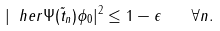<formula> <loc_0><loc_0><loc_500><loc_500>| \ h e r { \Psi ( \tilde { t } _ { n } ) } { \phi _ { 0 } } | ^ { 2 } \leq 1 - \epsilon \quad \forall n .</formula> 